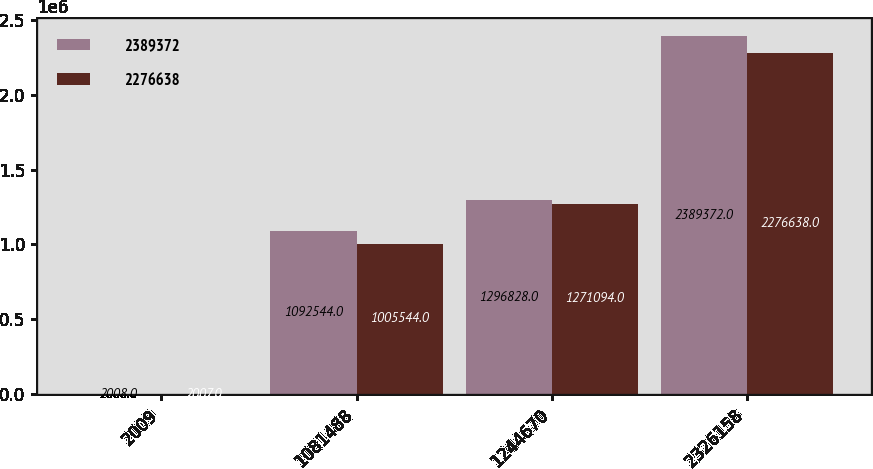<chart> <loc_0><loc_0><loc_500><loc_500><stacked_bar_chart><ecel><fcel>2009<fcel>1081488<fcel>1244670<fcel>2326158<nl><fcel>2.38937e+06<fcel>2008<fcel>1.09254e+06<fcel>1.29683e+06<fcel>2.38937e+06<nl><fcel>2.27664e+06<fcel>2007<fcel>1.00554e+06<fcel>1.27109e+06<fcel>2.27664e+06<nl></chart> 